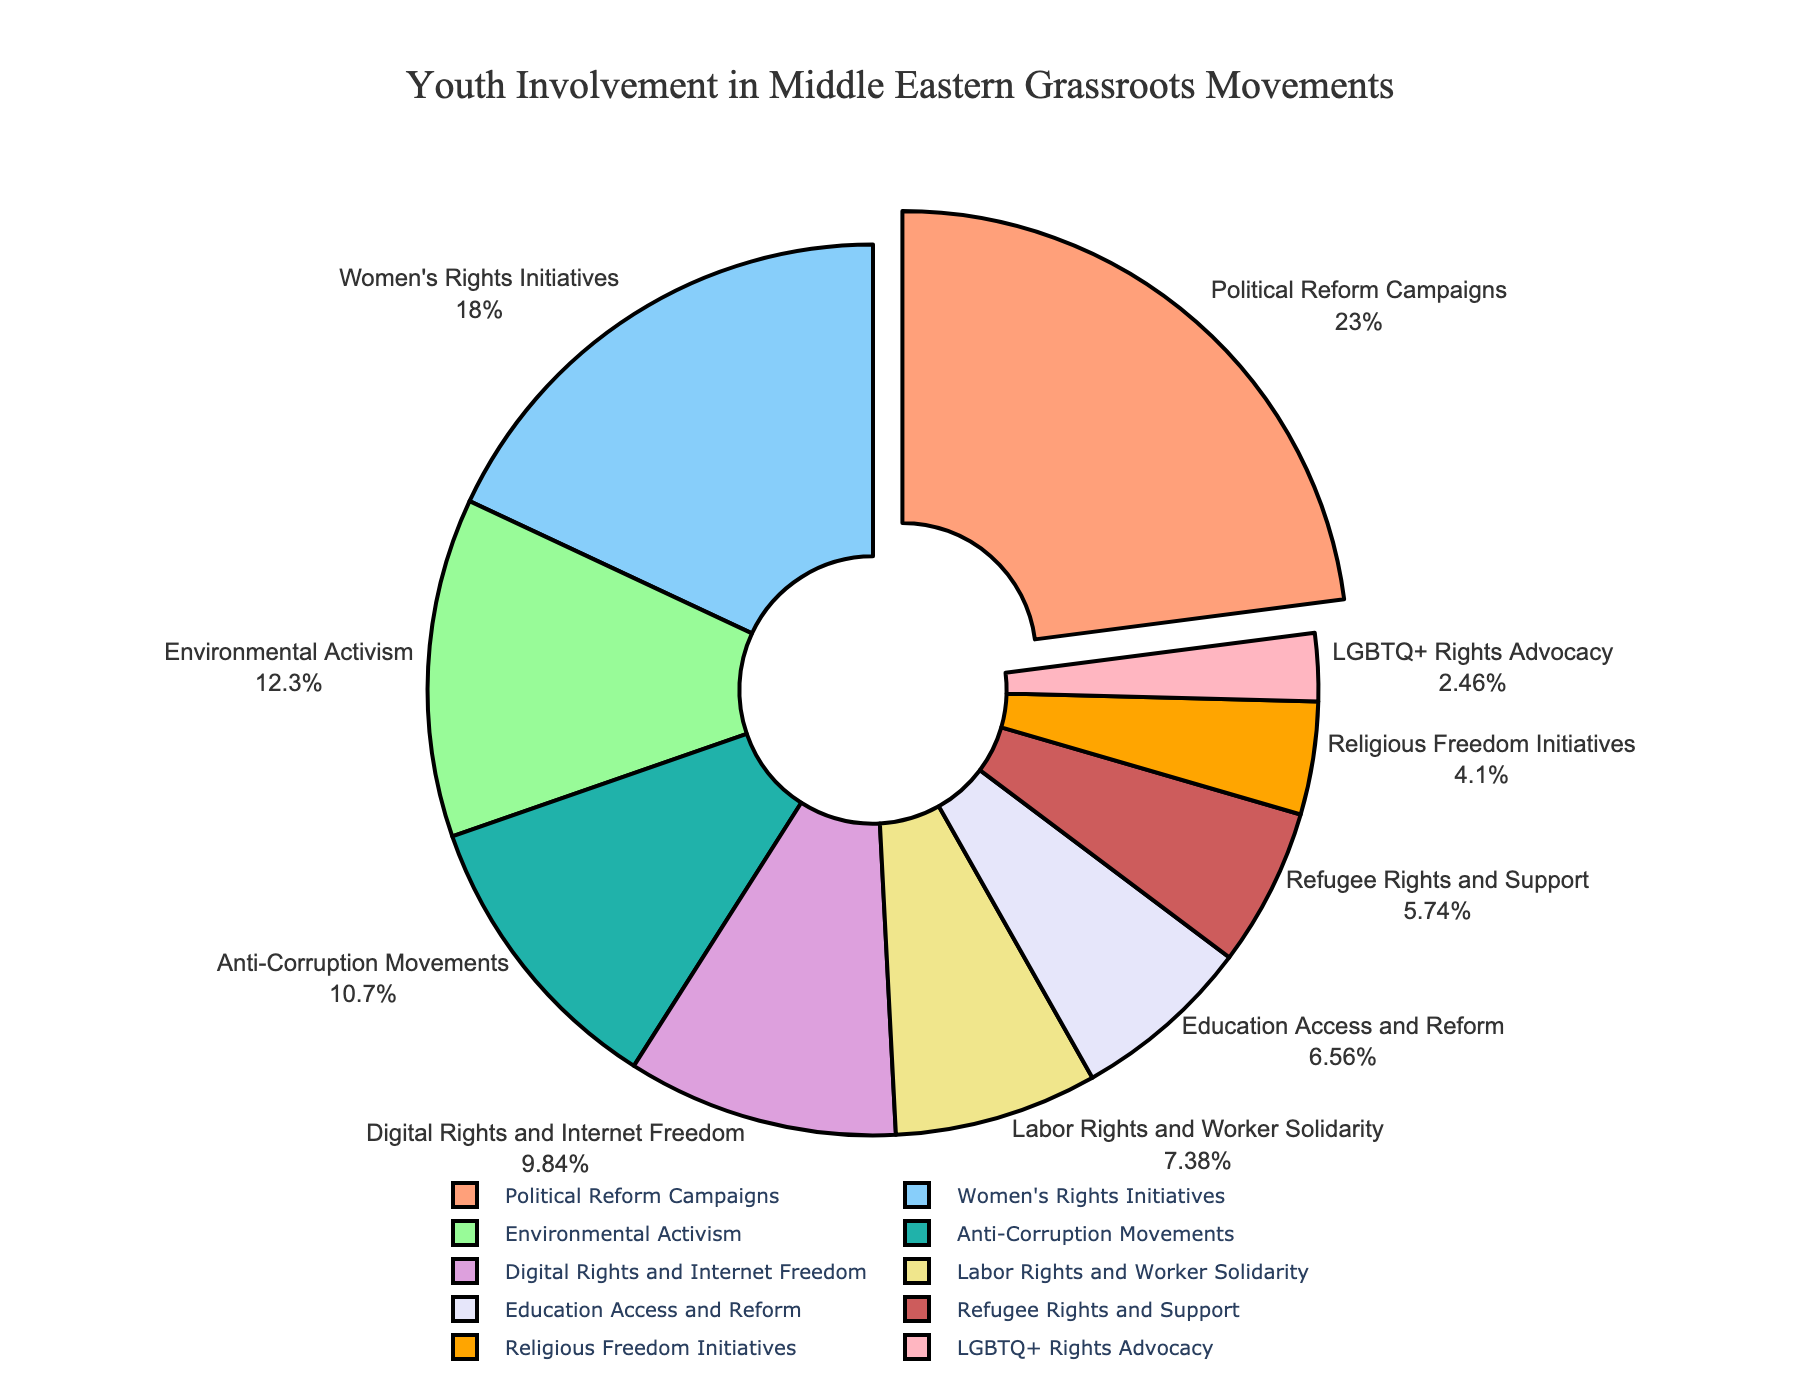Which type of grassroots movement has the highest percentage of youth involvement? The chart shows that the "Political Reform Campaigns" sector visually stands out, with the largest slice. As it's pulled out, it indicates it's the highest among all.
Answer: Political Reform Campaigns What is the combined percentage of youth involvement in Women's Rights Initiatives and Education Access and Reform? From the chart, Women's Rights Initiatives have 22% and Education Access and Reform has 8%. Adding them together gives 22% + 8% = 30%.
Answer: 30% Which movements occupy the smallest and the largest slices of the pie chart? Visually, the largest slice is "Political Reform Campaigns" and the smallest is "LGBTQ+ Rights Advocacy". The largest slice is pulled outwards, making it more noticeable.
Answer: Largest: Political Reform Campaigns, Smallest: LGBTQ+ Rights Advocacy Are there more youth involved in Anti-Corruption Movements or Environmental Activism? The pie chart shows Anti-Corruption Movements at 13% and Environmental Activism at 15%. Comparing these values, Environmental Activism is greater.
Answer: Environmental Activism How much more percentage of youth are involved in Political Reform Campaigns than in Digital Rights and Internet Freedom? Political Reform Campaigns have 28% while Digital Rights and Internet Freedom have 12%. The difference is 28% - 12% = 16%.
Answer: 16% What is the combined percentage of youth involvement across all movements except for Political Reform Campaigns? Total percentage is always 100%. Subtracting Political Reform Campaigns' 28% from the total gives 100% - 28% = 72%.
Answer: 72% Based on the chart, which color represents Environmental Activism? The slice for Environmental Activism stands out in the soft green shade amongst the other colors.
Answer: Green Among Women's Rights Initiatives, Religious Freedom Initiatives, and Refugee Rights and Support, which one has the highest youth involvement? According to the chart, Women's Rights Initiatives have 22%, Refugee Rights and Support have 7%, and Religious Freedom Initiatives have 5%. Women's Rights Initiatives is the highest among these.
Answer: Women's Rights Initiatives Which type of grassroots movement dealing with rights advocacy has the lowest percentage, and what is its percentage? Looking at the different rights advocacy categories, LGBTQ+ Rights Advocacy has the lowest percentage at 3%.
Answer: LGBTQ+ Rights Advocacy, 3% If you were to double the percentage of youth involvement in Labor Rights and Worker Solidarity, would it surpass Political Reform Campaigns? Labor Rights and Worker Solidarity have 9%. Doubling this percentage gives 9% * 2 = 18%. Political Reform Campaigns have 28%, which is still higher than 18%.
Answer: No 